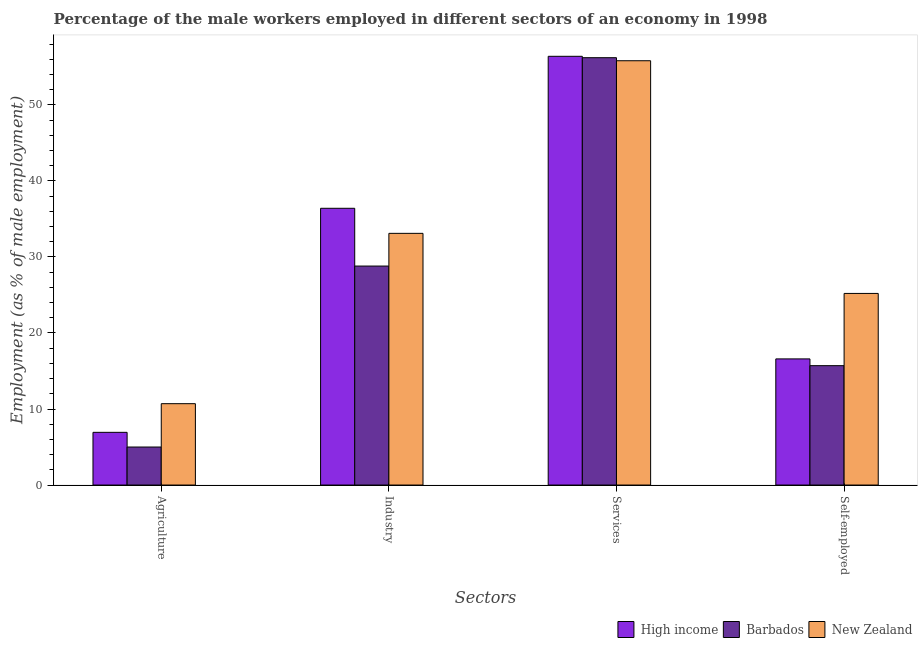How many groups of bars are there?
Give a very brief answer. 4. Are the number of bars per tick equal to the number of legend labels?
Keep it short and to the point. Yes. How many bars are there on the 1st tick from the left?
Make the answer very short. 3. How many bars are there on the 1st tick from the right?
Your answer should be compact. 3. What is the label of the 2nd group of bars from the left?
Provide a short and direct response. Industry. What is the percentage of male workers in services in New Zealand?
Your response must be concise. 55.8. Across all countries, what is the maximum percentage of self employed male workers?
Your response must be concise. 25.2. In which country was the percentage of self employed male workers maximum?
Your response must be concise. New Zealand. In which country was the percentage of male workers in agriculture minimum?
Your response must be concise. Barbados. What is the total percentage of male workers in services in the graph?
Your answer should be very brief. 168.38. What is the difference between the percentage of self employed male workers in New Zealand and that in High income?
Your response must be concise. 8.61. What is the difference between the percentage of self employed male workers in Barbados and the percentage of male workers in services in New Zealand?
Give a very brief answer. -40.1. What is the average percentage of male workers in services per country?
Your answer should be very brief. 56.13. What is the difference between the percentage of male workers in industry and percentage of self employed male workers in New Zealand?
Give a very brief answer. 7.9. In how many countries, is the percentage of male workers in industry greater than 20 %?
Your answer should be compact. 3. What is the ratio of the percentage of self employed male workers in New Zealand to that in High income?
Keep it short and to the point. 1.52. Is the percentage of male workers in agriculture in New Zealand less than that in Barbados?
Ensure brevity in your answer.  No. What is the difference between the highest and the second highest percentage of male workers in industry?
Provide a short and direct response. 3.3. What is the difference between the highest and the lowest percentage of male workers in services?
Your response must be concise. 0.58. Is the sum of the percentage of male workers in industry in New Zealand and High income greater than the maximum percentage of self employed male workers across all countries?
Keep it short and to the point. Yes. What does the 1st bar from the left in Self-employed represents?
Make the answer very short. High income. What does the 1st bar from the right in Services represents?
Keep it short and to the point. New Zealand. How many bars are there?
Offer a terse response. 12. How many countries are there in the graph?
Your answer should be compact. 3. What is the difference between two consecutive major ticks on the Y-axis?
Offer a very short reply. 10. Are the values on the major ticks of Y-axis written in scientific E-notation?
Your answer should be compact. No. Where does the legend appear in the graph?
Provide a succinct answer. Bottom right. How many legend labels are there?
Provide a short and direct response. 3. What is the title of the graph?
Keep it short and to the point. Percentage of the male workers employed in different sectors of an economy in 1998. What is the label or title of the X-axis?
Make the answer very short. Sectors. What is the label or title of the Y-axis?
Keep it short and to the point. Employment (as % of male employment). What is the Employment (as % of male employment) of High income in Agriculture?
Offer a very short reply. 6.93. What is the Employment (as % of male employment) in New Zealand in Agriculture?
Provide a short and direct response. 10.7. What is the Employment (as % of male employment) in High income in Industry?
Offer a terse response. 36.4. What is the Employment (as % of male employment) in Barbados in Industry?
Keep it short and to the point. 28.8. What is the Employment (as % of male employment) of New Zealand in Industry?
Offer a very short reply. 33.1. What is the Employment (as % of male employment) of High income in Services?
Offer a very short reply. 56.38. What is the Employment (as % of male employment) of Barbados in Services?
Your response must be concise. 56.2. What is the Employment (as % of male employment) in New Zealand in Services?
Your answer should be very brief. 55.8. What is the Employment (as % of male employment) of High income in Self-employed?
Ensure brevity in your answer.  16.59. What is the Employment (as % of male employment) of Barbados in Self-employed?
Offer a terse response. 15.7. What is the Employment (as % of male employment) of New Zealand in Self-employed?
Provide a short and direct response. 25.2. Across all Sectors, what is the maximum Employment (as % of male employment) of High income?
Provide a short and direct response. 56.38. Across all Sectors, what is the maximum Employment (as % of male employment) in Barbados?
Provide a succinct answer. 56.2. Across all Sectors, what is the maximum Employment (as % of male employment) in New Zealand?
Give a very brief answer. 55.8. Across all Sectors, what is the minimum Employment (as % of male employment) in High income?
Provide a short and direct response. 6.93. Across all Sectors, what is the minimum Employment (as % of male employment) of Barbados?
Ensure brevity in your answer.  5. Across all Sectors, what is the minimum Employment (as % of male employment) of New Zealand?
Offer a terse response. 10.7. What is the total Employment (as % of male employment) in High income in the graph?
Your answer should be very brief. 116.3. What is the total Employment (as % of male employment) of Barbados in the graph?
Make the answer very short. 105.7. What is the total Employment (as % of male employment) in New Zealand in the graph?
Ensure brevity in your answer.  124.8. What is the difference between the Employment (as % of male employment) of High income in Agriculture and that in Industry?
Your answer should be compact. -29.46. What is the difference between the Employment (as % of male employment) in Barbados in Agriculture and that in Industry?
Your answer should be compact. -23.8. What is the difference between the Employment (as % of male employment) in New Zealand in Agriculture and that in Industry?
Offer a terse response. -22.4. What is the difference between the Employment (as % of male employment) in High income in Agriculture and that in Services?
Ensure brevity in your answer.  -49.45. What is the difference between the Employment (as % of male employment) in Barbados in Agriculture and that in Services?
Make the answer very short. -51.2. What is the difference between the Employment (as % of male employment) in New Zealand in Agriculture and that in Services?
Your response must be concise. -45.1. What is the difference between the Employment (as % of male employment) in High income in Agriculture and that in Self-employed?
Make the answer very short. -9.66. What is the difference between the Employment (as % of male employment) of New Zealand in Agriculture and that in Self-employed?
Provide a short and direct response. -14.5. What is the difference between the Employment (as % of male employment) in High income in Industry and that in Services?
Offer a very short reply. -19.99. What is the difference between the Employment (as % of male employment) of Barbados in Industry and that in Services?
Ensure brevity in your answer.  -27.4. What is the difference between the Employment (as % of male employment) of New Zealand in Industry and that in Services?
Your answer should be compact. -22.7. What is the difference between the Employment (as % of male employment) in High income in Industry and that in Self-employed?
Make the answer very short. 19.81. What is the difference between the Employment (as % of male employment) in Barbados in Industry and that in Self-employed?
Your answer should be compact. 13.1. What is the difference between the Employment (as % of male employment) of New Zealand in Industry and that in Self-employed?
Offer a terse response. 7.9. What is the difference between the Employment (as % of male employment) in High income in Services and that in Self-employed?
Your answer should be compact. 39.79. What is the difference between the Employment (as % of male employment) in Barbados in Services and that in Self-employed?
Your answer should be very brief. 40.5. What is the difference between the Employment (as % of male employment) of New Zealand in Services and that in Self-employed?
Provide a short and direct response. 30.6. What is the difference between the Employment (as % of male employment) in High income in Agriculture and the Employment (as % of male employment) in Barbados in Industry?
Your response must be concise. -21.87. What is the difference between the Employment (as % of male employment) of High income in Agriculture and the Employment (as % of male employment) of New Zealand in Industry?
Your answer should be very brief. -26.17. What is the difference between the Employment (as % of male employment) in Barbados in Agriculture and the Employment (as % of male employment) in New Zealand in Industry?
Ensure brevity in your answer.  -28.1. What is the difference between the Employment (as % of male employment) of High income in Agriculture and the Employment (as % of male employment) of Barbados in Services?
Offer a terse response. -49.27. What is the difference between the Employment (as % of male employment) of High income in Agriculture and the Employment (as % of male employment) of New Zealand in Services?
Your response must be concise. -48.87. What is the difference between the Employment (as % of male employment) in Barbados in Agriculture and the Employment (as % of male employment) in New Zealand in Services?
Provide a succinct answer. -50.8. What is the difference between the Employment (as % of male employment) of High income in Agriculture and the Employment (as % of male employment) of Barbados in Self-employed?
Give a very brief answer. -8.77. What is the difference between the Employment (as % of male employment) in High income in Agriculture and the Employment (as % of male employment) in New Zealand in Self-employed?
Provide a short and direct response. -18.27. What is the difference between the Employment (as % of male employment) of Barbados in Agriculture and the Employment (as % of male employment) of New Zealand in Self-employed?
Your response must be concise. -20.2. What is the difference between the Employment (as % of male employment) of High income in Industry and the Employment (as % of male employment) of Barbados in Services?
Provide a succinct answer. -19.8. What is the difference between the Employment (as % of male employment) of High income in Industry and the Employment (as % of male employment) of New Zealand in Services?
Offer a very short reply. -19.4. What is the difference between the Employment (as % of male employment) in Barbados in Industry and the Employment (as % of male employment) in New Zealand in Services?
Provide a short and direct response. -27. What is the difference between the Employment (as % of male employment) in High income in Industry and the Employment (as % of male employment) in Barbados in Self-employed?
Give a very brief answer. 20.7. What is the difference between the Employment (as % of male employment) in High income in Industry and the Employment (as % of male employment) in New Zealand in Self-employed?
Offer a terse response. 11.2. What is the difference between the Employment (as % of male employment) in High income in Services and the Employment (as % of male employment) in Barbados in Self-employed?
Your answer should be very brief. 40.68. What is the difference between the Employment (as % of male employment) of High income in Services and the Employment (as % of male employment) of New Zealand in Self-employed?
Your response must be concise. 31.18. What is the difference between the Employment (as % of male employment) of Barbados in Services and the Employment (as % of male employment) of New Zealand in Self-employed?
Provide a short and direct response. 31. What is the average Employment (as % of male employment) of High income per Sectors?
Your response must be concise. 29.07. What is the average Employment (as % of male employment) in Barbados per Sectors?
Your answer should be very brief. 26.43. What is the average Employment (as % of male employment) of New Zealand per Sectors?
Provide a short and direct response. 31.2. What is the difference between the Employment (as % of male employment) of High income and Employment (as % of male employment) of Barbados in Agriculture?
Keep it short and to the point. 1.93. What is the difference between the Employment (as % of male employment) in High income and Employment (as % of male employment) in New Zealand in Agriculture?
Provide a succinct answer. -3.77. What is the difference between the Employment (as % of male employment) of High income and Employment (as % of male employment) of Barbados in Industry?
Provide a short and direct response. 7.6. What is the difference between the Employment (as % of male employment) of High income and Employment (as % of male employment) of New Zealand in Industry?
Ensure brevity in your answer.  3.3. What is the difference between the Employment (as % of male employment) in High income and Employment (as % of male employment) in Barbados in Services?
Your answer should be compact. 0.18. What is the difference between the Employment (as % of male employment) in High income and Employment (as % of male employment) in New Zealand in Services?
Make the answer very short. 0.58. What is the difference between the Employment (as % of male employment) of Barbados and Employment (as % of male employment) of New Zealand in Services?
Keep it short and to the point. 0.4. What is the difference between the Employment (as % of male employment) of High income and Employment (as % of male employment) of Barbados in Self-employed?
Offer a terse response. 0.89. What is the difference between the Employment (as % of male employment) of High income and Employment (as % of male employment) of New Zealand in Self-employed?
Provide a short and direct response. -8.61. What is the difference between the Employment (as % of male employment) of Barbados and Employment (as % of male employment) of New Zealand in Self-employed?
Keep it short and to the point. -9.5. What is the ratio of the Employment (as % of male employment) of High income in Agriculture to that in Industry?
Offer a very short reply. 0.19. What is the ratio of the Employment (as % of male employment) of Barbados in Agriculture to that in Industry?
Your answer should be very brief. 0.17. What is the ratio of the Employment (as % of male employment) in New Zealand in Agriculture to that in Industry?
Offer a terse response. 0.32. What is the ratio of the Employment (as % of male employment) in High income in Agriculture to that in Services?
Keep it short and to the point. 0.12. What is the ratio of the Employment (as % of male employment) in Barbados in Agriculture to that in Services?
Keep it short and to the point. 0.09. What is the ratio of the Employment (as % of male employment) of New Zealand in Agriculture to that in Services?
Your response must be concise. 0.19. What is the ratio of the Employment (as % of male employment) of High income in Agriculture to that in Self-employed?
Offer a terse response. 0.42. What is the ratio of the Employment (as % of male employment) in Barbados in Agriculture to that in Self-employed?
Offer a very short reply. 0.32. What is the ratio of the Employment (as % of male employment) of New Zealand in Agriculture to that in Self-employed?
Offer a very short reply. 0.42. What is the ratio of the Employment (as % of male employment) in High income in Industry to that in Services?
Offer a terse response. 0.65. What is the ratio of the Employment (as % of male employment) of Barbados in Industry to that in Services?
Your response must be concise. 0.51. What is the ratio of the Employment (as % of male employment) in New Zealand in Industry to that in Services?
Keep it short and to the point. 0.59. What is the ratio of the Employment (as % of male employment) in High income in Industry to that in Self-employed?
Your answer should be very brief. 2.19. What is the ratio of the Employment (as % of male employment) of Barbados in Industry to that in Self-employed?
Your answer should be compact. 1.83. What is the ratio of the Employment (as % of male employment) in New Zealand in Industry to that in Self-employed?
Provide a short and direct response. 1.31. What is the ratio of the Employment (as % of male employment) in High income in Services to that in Self-employed?
Offer a very short reply. 3.4. What is the ratio of the Employment (as % of male employment) in Barbados in Services to that in Self-employed?
Your answer should be compact. 3.58. What is the ratio of the Employment (as % of male employment) of New Zealand in Services to that in Self-employed?
Offer a terse response. 2.21. What is the difference between the highest and the second highest Employment (as % of male employment) of High income?
Offer a very short reply. 19.99. What is the difference between the highest and the second highest Employment (as % of male employment) of Barbados?
Your response must be concise. 27.4. What is the difference between the highest and the second highest Employment (as % of male employment) in New Zealand?
Provide a short and direct response. 22.7. What is the difference between the highest and the lowest Employment (as % of male employment) of High income?
Provide a short and direct response. 49.45. What is the difference between the highest and the lowest Employment (as % of male employment) in Barbados?
Provide a short and direct response. 51.2. What is the difference between the highest and the lowest Employment (as % of male employment) of New Zealand?
Keep it short and to the point. 45.1. 